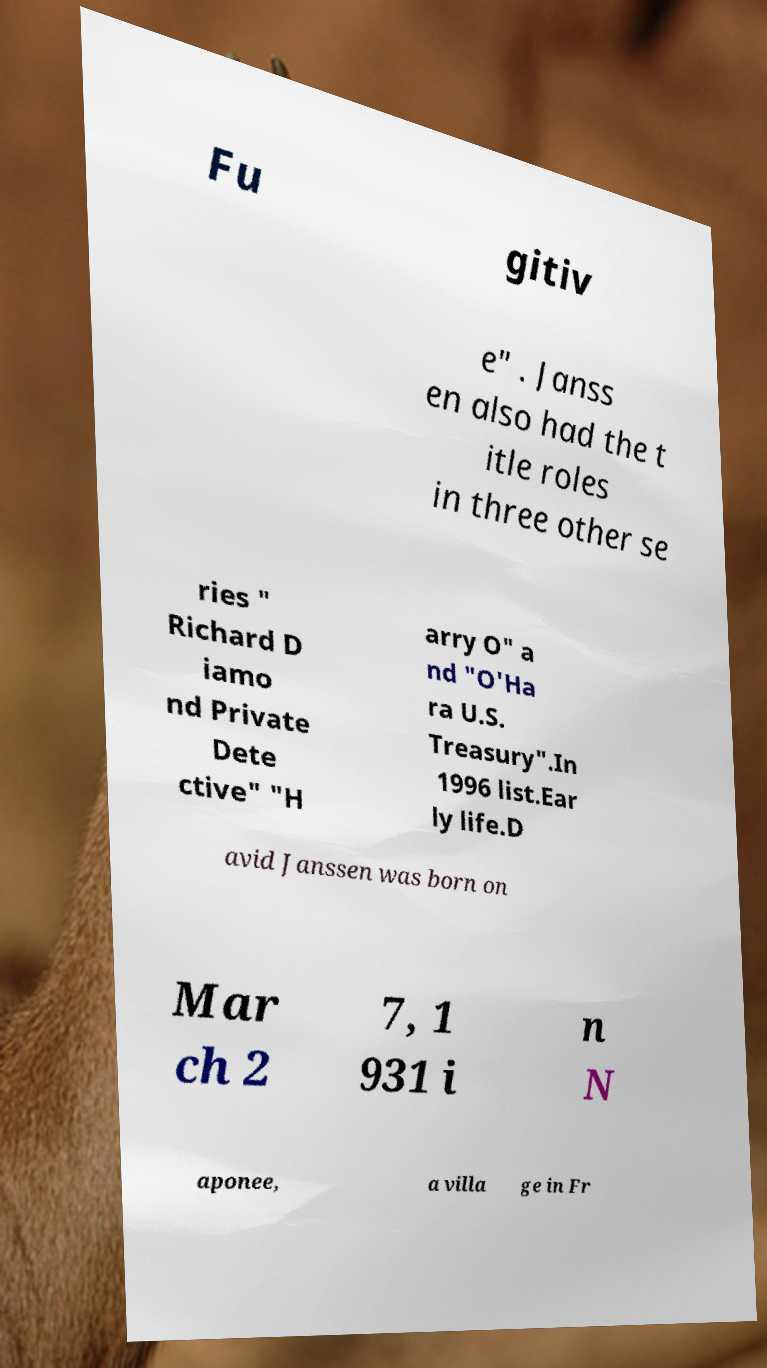I need the written content from this picture converted into text. Can you do that? Fu gitiv e" . Janss en also had the t itle roles in three other se ries " Richard D iamo nd Private Dete ctive" "H arry O" a nd "O'Ha ra U.S. Treasury".In 1996 list.Ear ly life.D avid Janssen was born on Mar ch 2 7, 1 931 i n N aponee, a villa ge in Fr 